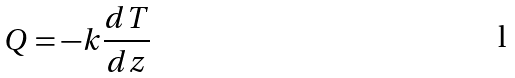Convert formula to latex. <formula><loc_0><loc_0><loc_500><loc_500>Q = - k \frac { d T } { d z }</formula> 